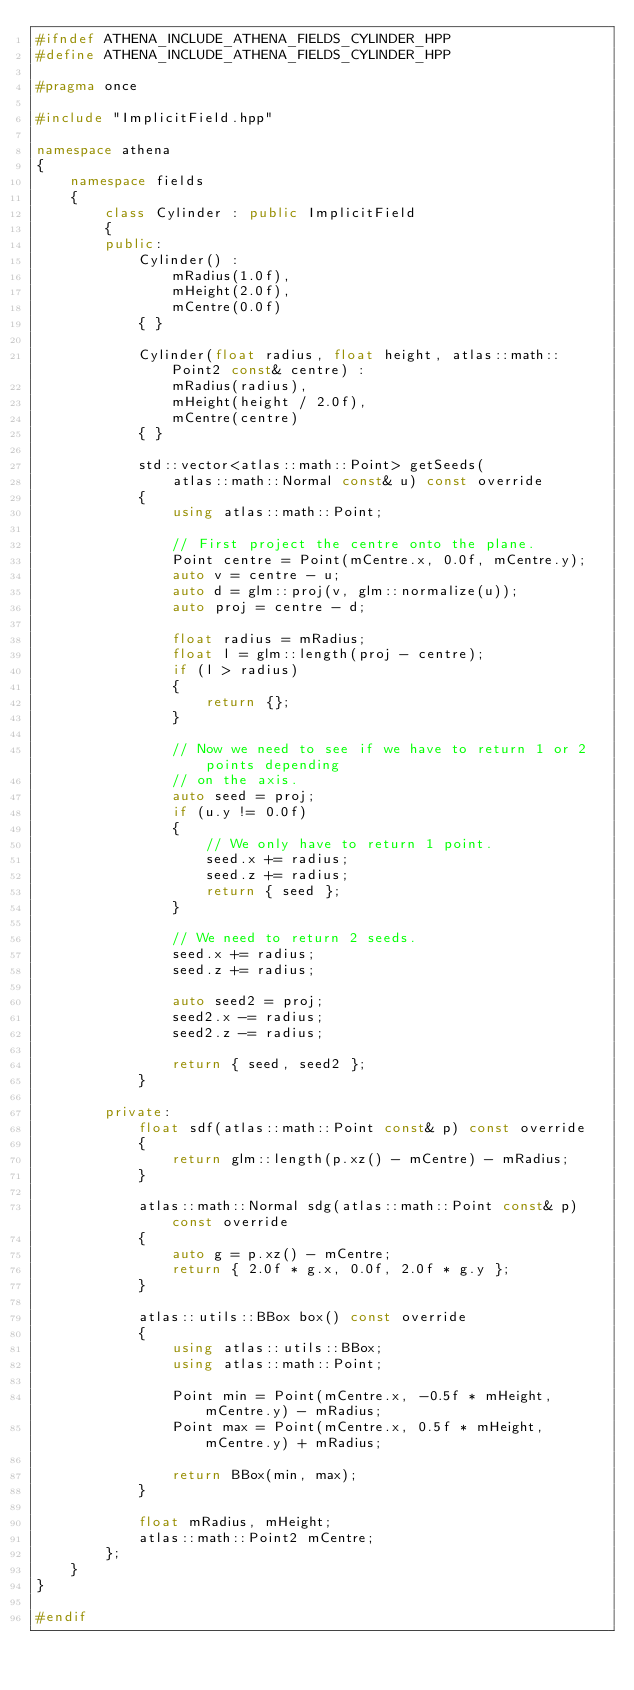<code> <loc_0><loc_0><loc_500><loc_500><_C++_>#ifndef ATHENA_INCLUDE_ATHENA_FIELDS_CYLINDER_HPP
#define ATHENA_INCLUDE_ATHENA_FIELDS_CYLINDER_HPP

#pragma once

#include "ImplicitField.hpp"

namespace athena
{
    namespace fields
    {
        class Cylinder : public ImplicitField
        {
        public:
            Cylinder() :
                mRadius(1.0f),
                mHeight(2.0f),
                mCentre(0.0f)
            { }

            Cylinder(float radius, float height, atlas::math::Point2 const& centre) :
                mRadius(radius),
                mHeight(height / 2.0f),
                mCentre(centre)
            { }

            std::vector<atlas::math::Point> getSeeds(
                atlas::math::Normal const& u) const override
            {
                using atlas::math::Point;

                // First project the centre onto the plane.
                Point centre = Point(mCentre.x, 0.0f, mCentre.y);
                auto v = centre - u;
                auto d = glm::proj(v, glm::normalize(u));
                auto proj = centre - d;

                float radius = mRadius;
                float l = glm::length(proj - centre);
                if (l > radius)
                {
                    return {};
                }

                // Now we need to see if we have to return 1 or 2 points depending
                // on the axis.
                auto seed = proj;
                if (u.y != 0.0f)
                {
                    // We only have to return 1 point.
                    seed.x += radius;
                    seed.z += radius;
                    return { seed };
                }

                // We need to return 2 seeds.
                seed.x += radius;
                seed.z += radius;

                auto seed2 = proj;
                seed2.x -= radius;
                seed2.z -= radius;

                return { seed, seed2 };
            }

        private:
            float sdf(atlas::math::Point const& p) const override
            {
                return glm::length(p.xz() - mCentre) - mRadius;
            }

            atlas::math::Normal sdg(atlas::math::Point const& p) const override
            {
                auto g = p.xz() - mCentre;
                return { 2.0f * g.x, 0.0f, 2.0f * g.y };
            }

            atlas::utils::BBox box() const override
            {
                using atlas::utils::BBox;
                using atlas::math::Point;

                Point min = Point(mCentre.x, -0.5f * mHeight, mCentre.y) - mRadius;
                Point max = Point(mCentre.x, 0.5f * mHeight, mCentre.y) + mRadius;

                return BBox(min, max);
            }

            float mRadius, mHeight;
            atlas::math::Point2 mCentre;
        };
    }
}

#endif
</code> 